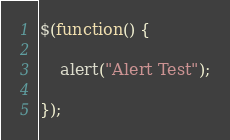Convert code to text. <code><loc_0><loc_0><loc_500><loc_500><_JavaScript_>$(function() {

    alert("Alert Test");

});</code> 